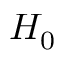Convert formula to latex. <formula><loc_0><loc_0><loc_500><loc_500>H _ { 0 }</formula> 